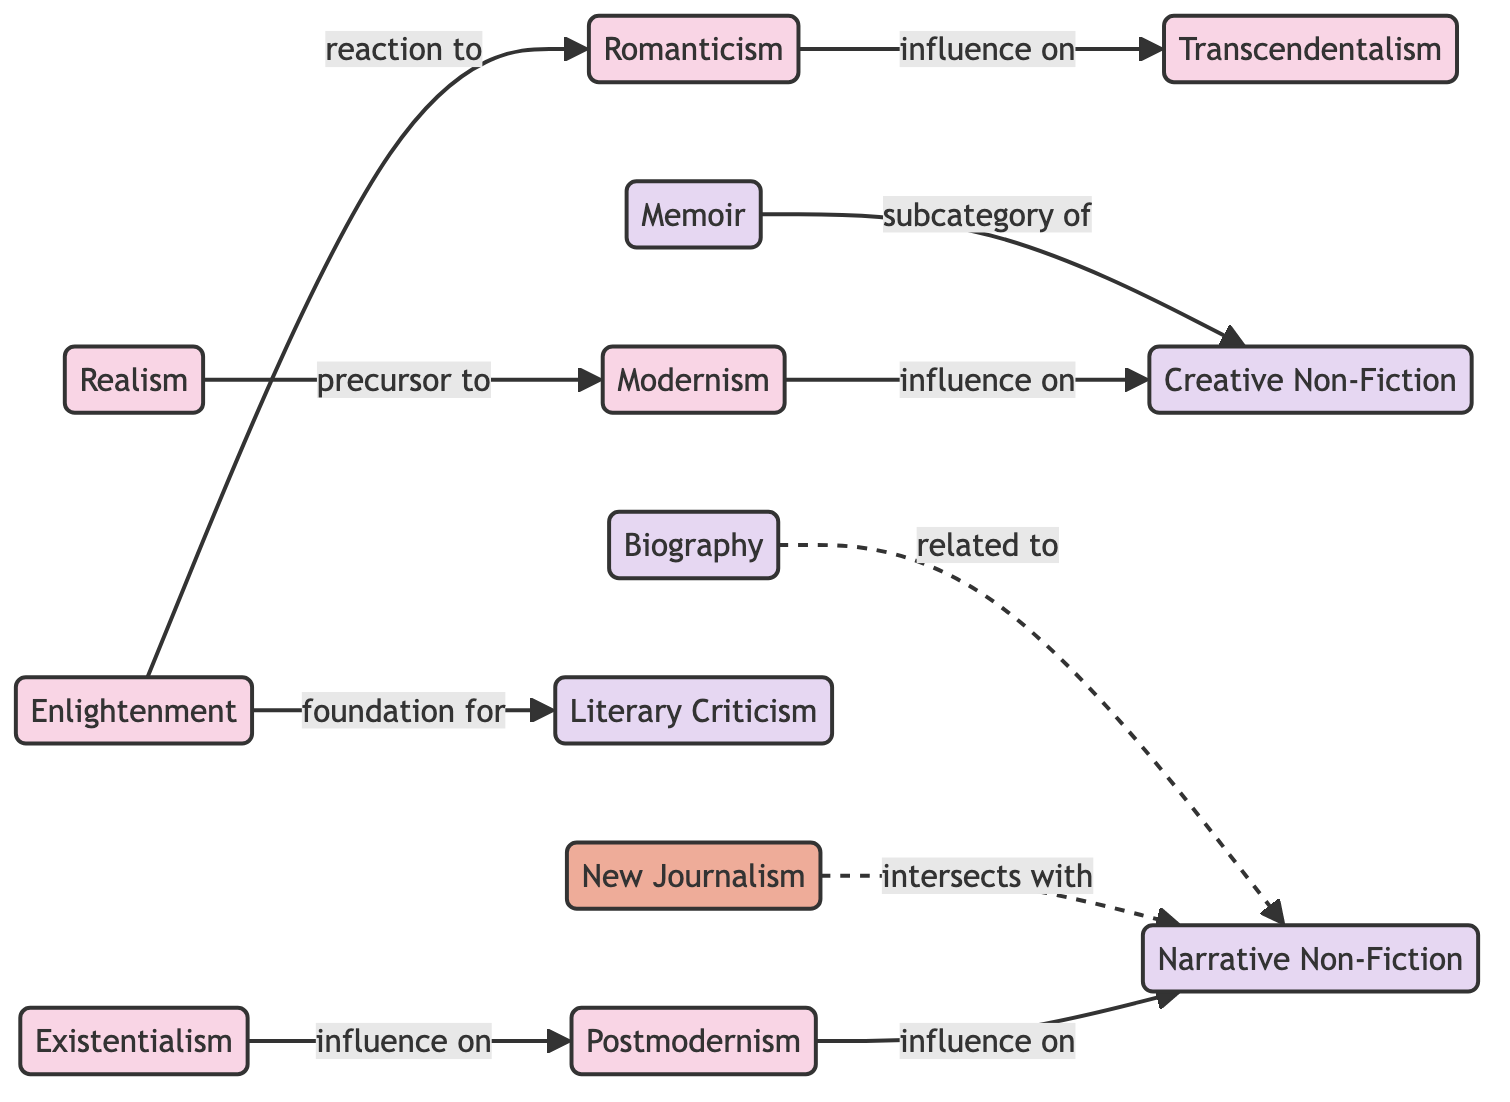What are the total number of nodes in the diagram? Counting the nodes listed in the data, we find there are 12 distinct nodes representing different themes and genres in non-fiction writing.
Answer: 12 Which node is identified as a reaction to Romanticism? The diagram shows that Enlightenment has a directed edge labeled "reaction to" that points towards Romanticism, indicating this relationship.
Answer: Enlightenment What themes influence Narrative Non-Fiction? By following the edges in the diagram, we can see that Postmodernism has a directed edge labeled "influence on" that points to Narrative Non-Fiction, indicating a direct influence. Additionally, New Journalism intersects with Narrative Non-Fiction, forming a connection.
Answer: Postmodernism, New Journalism Which theme is a precursor to Modernism? The diagram indicates that Realism has a directed edge labeled "precursor to" leading to Modernism. This shows that Realism sets the stage for Modernism in the flow of literary history.
Answer: Realism What relationship does Memoir have with Creative Non-Fiction? The diagram shows that Memoir is a subcategory of Creative Non-Fiction, with a direct edge labeled "subcategory of" pointing from Memoir to Creative Non-Fiction. This indicates the classification within the genre.
Answer: subcategory of How many types of relationships can be found in the diagram? In the diagram, relationships include "reaction to," "influence on," "precursor to," "intersects with," and "related to." Counting these distinct types of relationships results in five.
Answer: 5 Which two themes show an influence on Narrative Non-Fiction? Reviewing the edges that lead to Narrative Non-Fiction reveals that it is influenced by Postmodernism and related to Biography, showing these connections as significant influences on elements of Narrative Non-Fiction.
Answer: Postmodernism, Biography What is the direct relationship between New Journalism and Narrative Non-Fiction? The diagram illustrates that New Journalism "intersects with" Narrative Non-Fiction, indicating a non-hierarchical relationship that connects both movements without suggesting direct lineage.
Answer: intersects with 